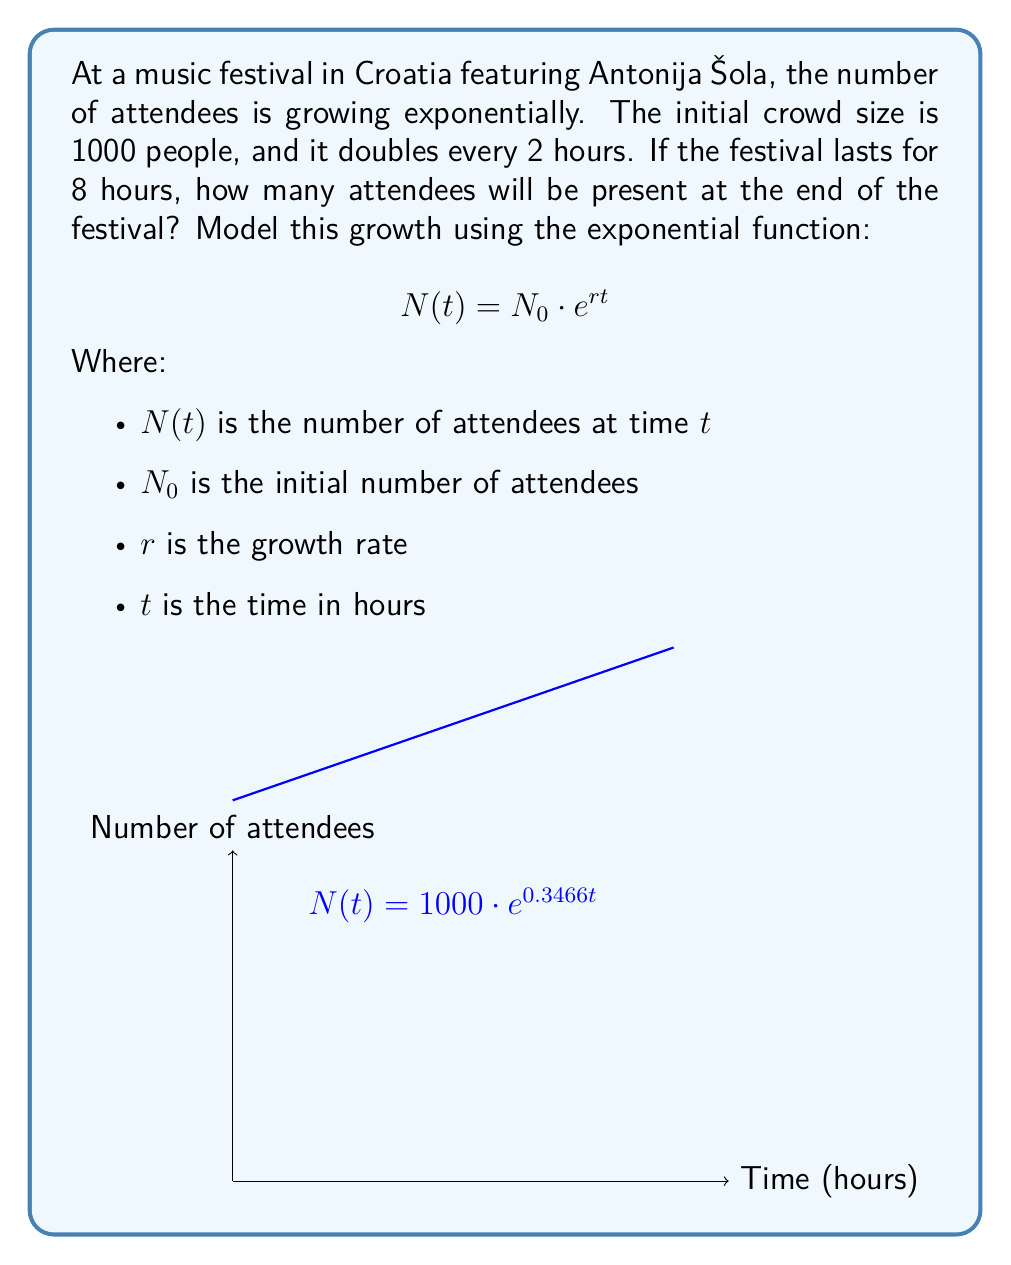Can you solve this math problem? To solve this problem, we'll follow these steps:

1) First, we need to find the growth rate $r$. We know the population doubles every 2 hours, so:

   $$2N_0 = N_0 \cdot e^{2r}$$
   $$2 = e^{2r}$$
   $$\ln(2) = 2r$$
   $$r = \frac{\ln(2)}{2} \approx 0.3466$$

2) Now we have all the parameters for our model:
   $N_0 = 1000$ (initial attendees)
   $r \approx 0.3466$ (growth rate)
   $t = 8$ (festival duration in hours)

3) We can plug these into our exponential growth formula:

   $$N(8) = 1000 \cdot e^{0.3466 \cdot 8}$$

4) Calculate:
   $$N(8) = 1000 \cdot e^{2.7728}$$
   $$N(8) = 1000 \cdot 16$$
   $$N(8) = 16000$$

Therefore, after 8 hours, there will be 16,000 attendees at the festival.
Answer: 16,000 attendees 